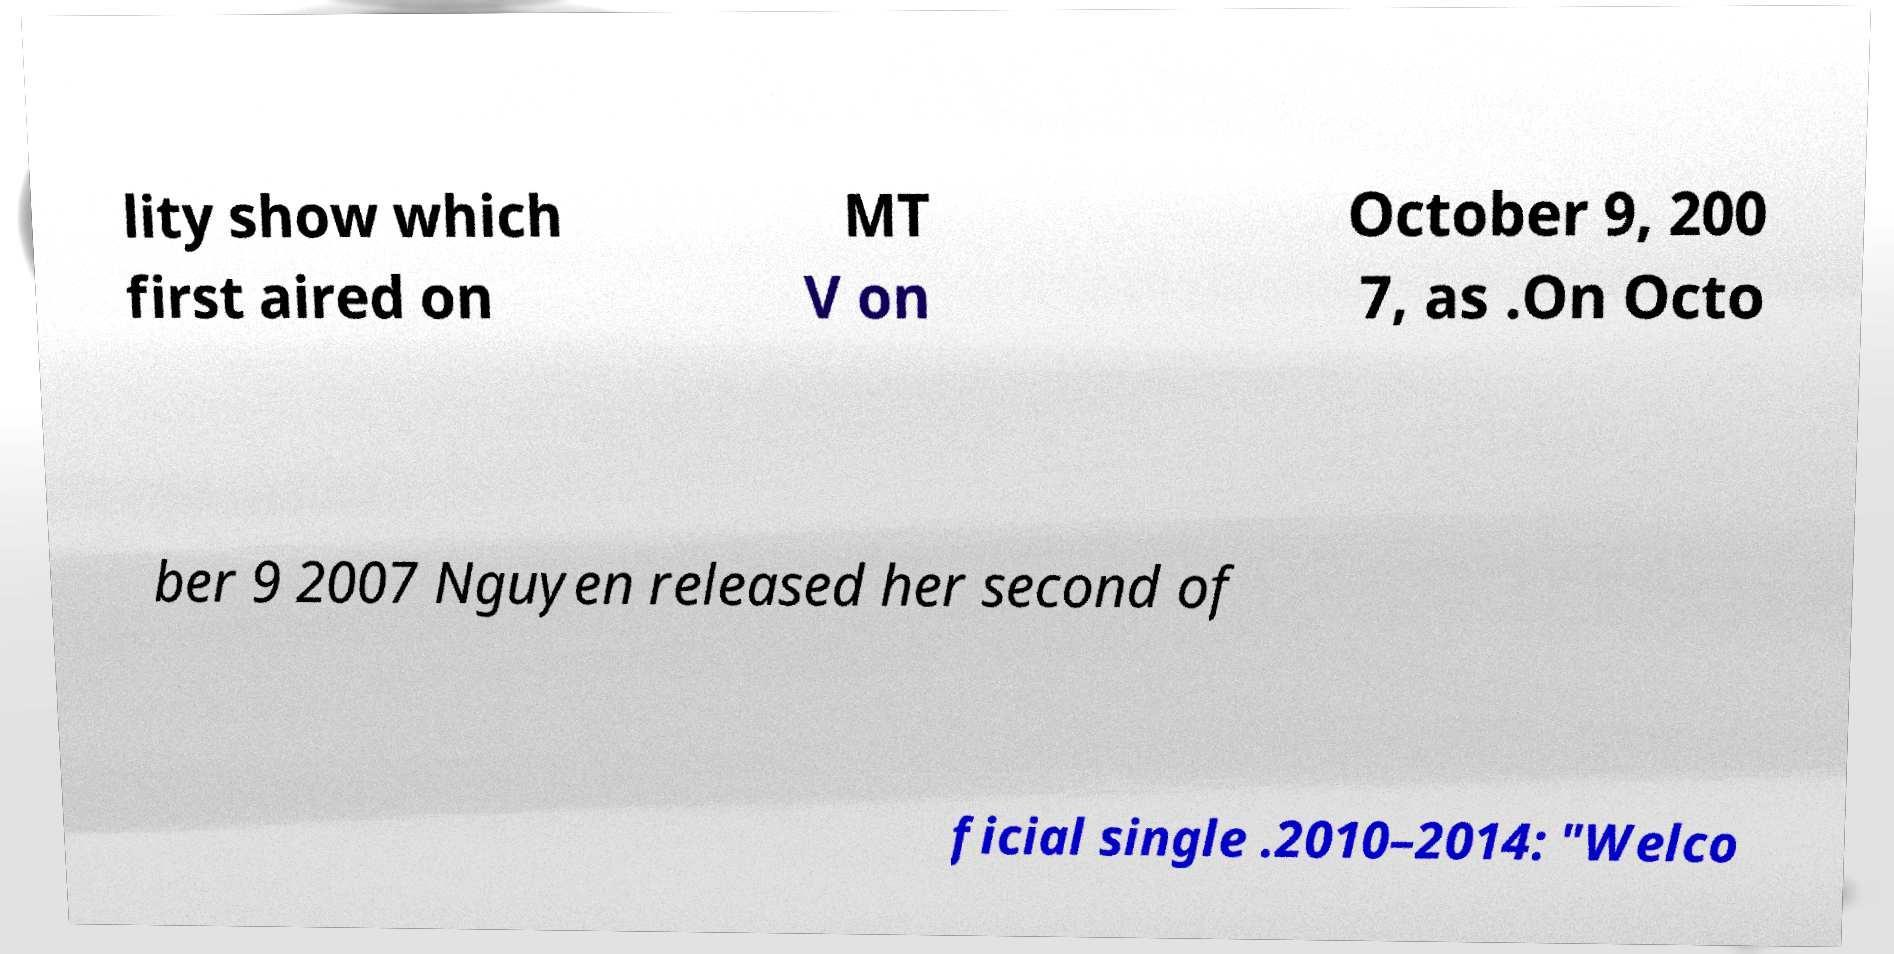Can you accurately transcribe the text from the provided image for me? lity show which first aired on MT V on October 9, 200 7, as .On Octo ber 9 2007 Nguyen released her second of ficial single .2010–2014: "Welco 